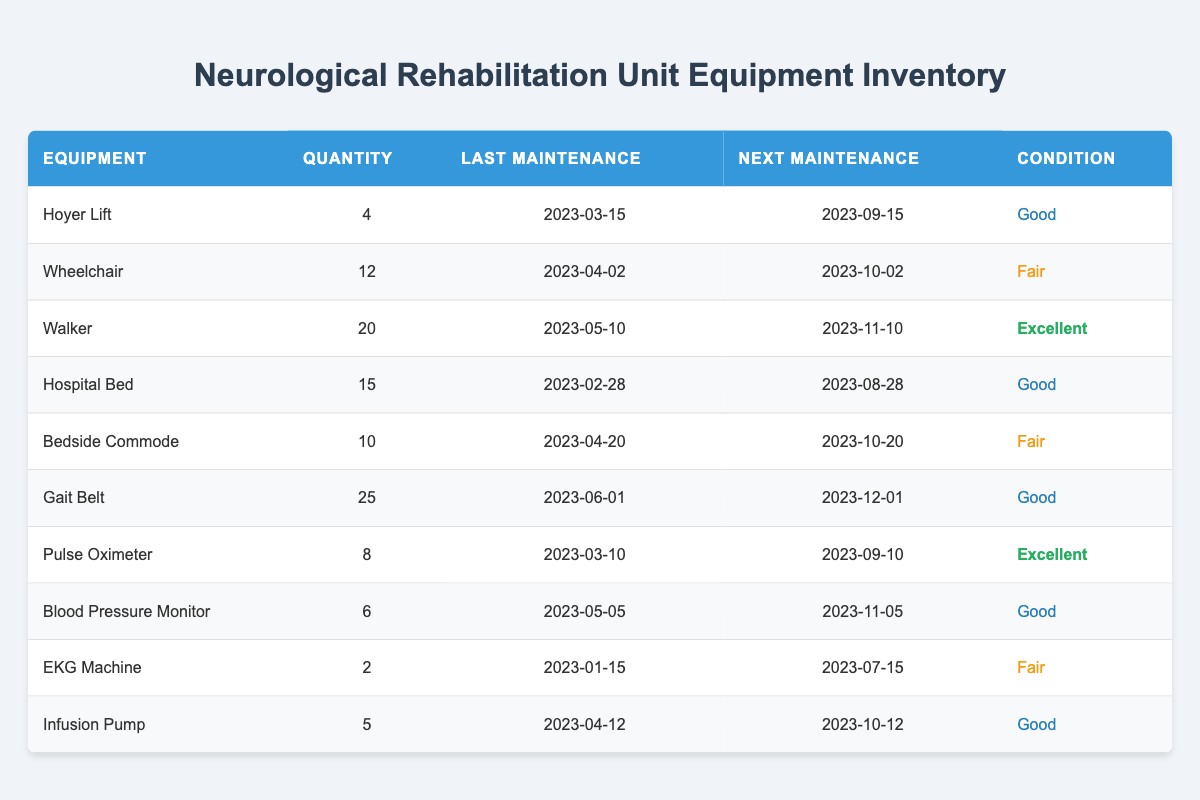What is the quantity of Wheelchairs available? The table lists "Wheelchair" under the Equipment column, and the Quantity column shows the value 12 next to it.
Answer: 12 When is the next maintenance scheduled for the Blood Pressure Monitor? By looking at the Blood Pressure Monitor row, the table indicates that the Next Maintenance date is 2023-11-05.
Answer: 2023-11-05 How many pieces of equipment are in "Good" condition? The conditions labeled as "Good" are for Hoyer Lift, Hospital Bed, Gait Belt, Pulse Oximeter, and Blood Pressure Monitor, which counts to a total of 5 equipment pieces.
Answer: 5 Is the EKG Machine in "Excellent" condition? In the table, the EKG Machine is listed under the Condition column as "Fair," so it is not in excellent condition.
Answer: No What is the average quantity of equipment listed in the table? First, you sum the quantities: 4 + 12 + 20 + 15 + 10 + 25 + 8 + 6 + 2 + 5 = 107. Then, divide by the number of equipment types, which is 10, giving an average of 107/10 = 10.7.
Answer: 10.7 Which equipment has the earliest last maintenance date? The table shows the last maintenance dates: 2023-01-15 (EKG Machine), 2023-02-28 (Hospital Bed), 2023-03-15 (Hoyer Lift), etc. The earliest date is for the EKG Machine on 2023-01-15.
Answer: EKG Machine How many pieces of equipment need maintenance before October? The next maintenance dates before October are for Hoyer Lift, Hospital Bed, Pulse Oximeter, and Blood Pressure Monitor, totaling to 4 pieces that require maintenance before October 2023.
Answer: 4 What equipment has the most quantity? In the table, the Gait Belt has the highest quantity listed at 25, which is greater than the other equipment quantities.
Answer: Gait Belt 